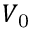Convert formula to latex. <formula><loc_0><loc_0><loc_500><loc_500>V _ { 0 }</formula> 